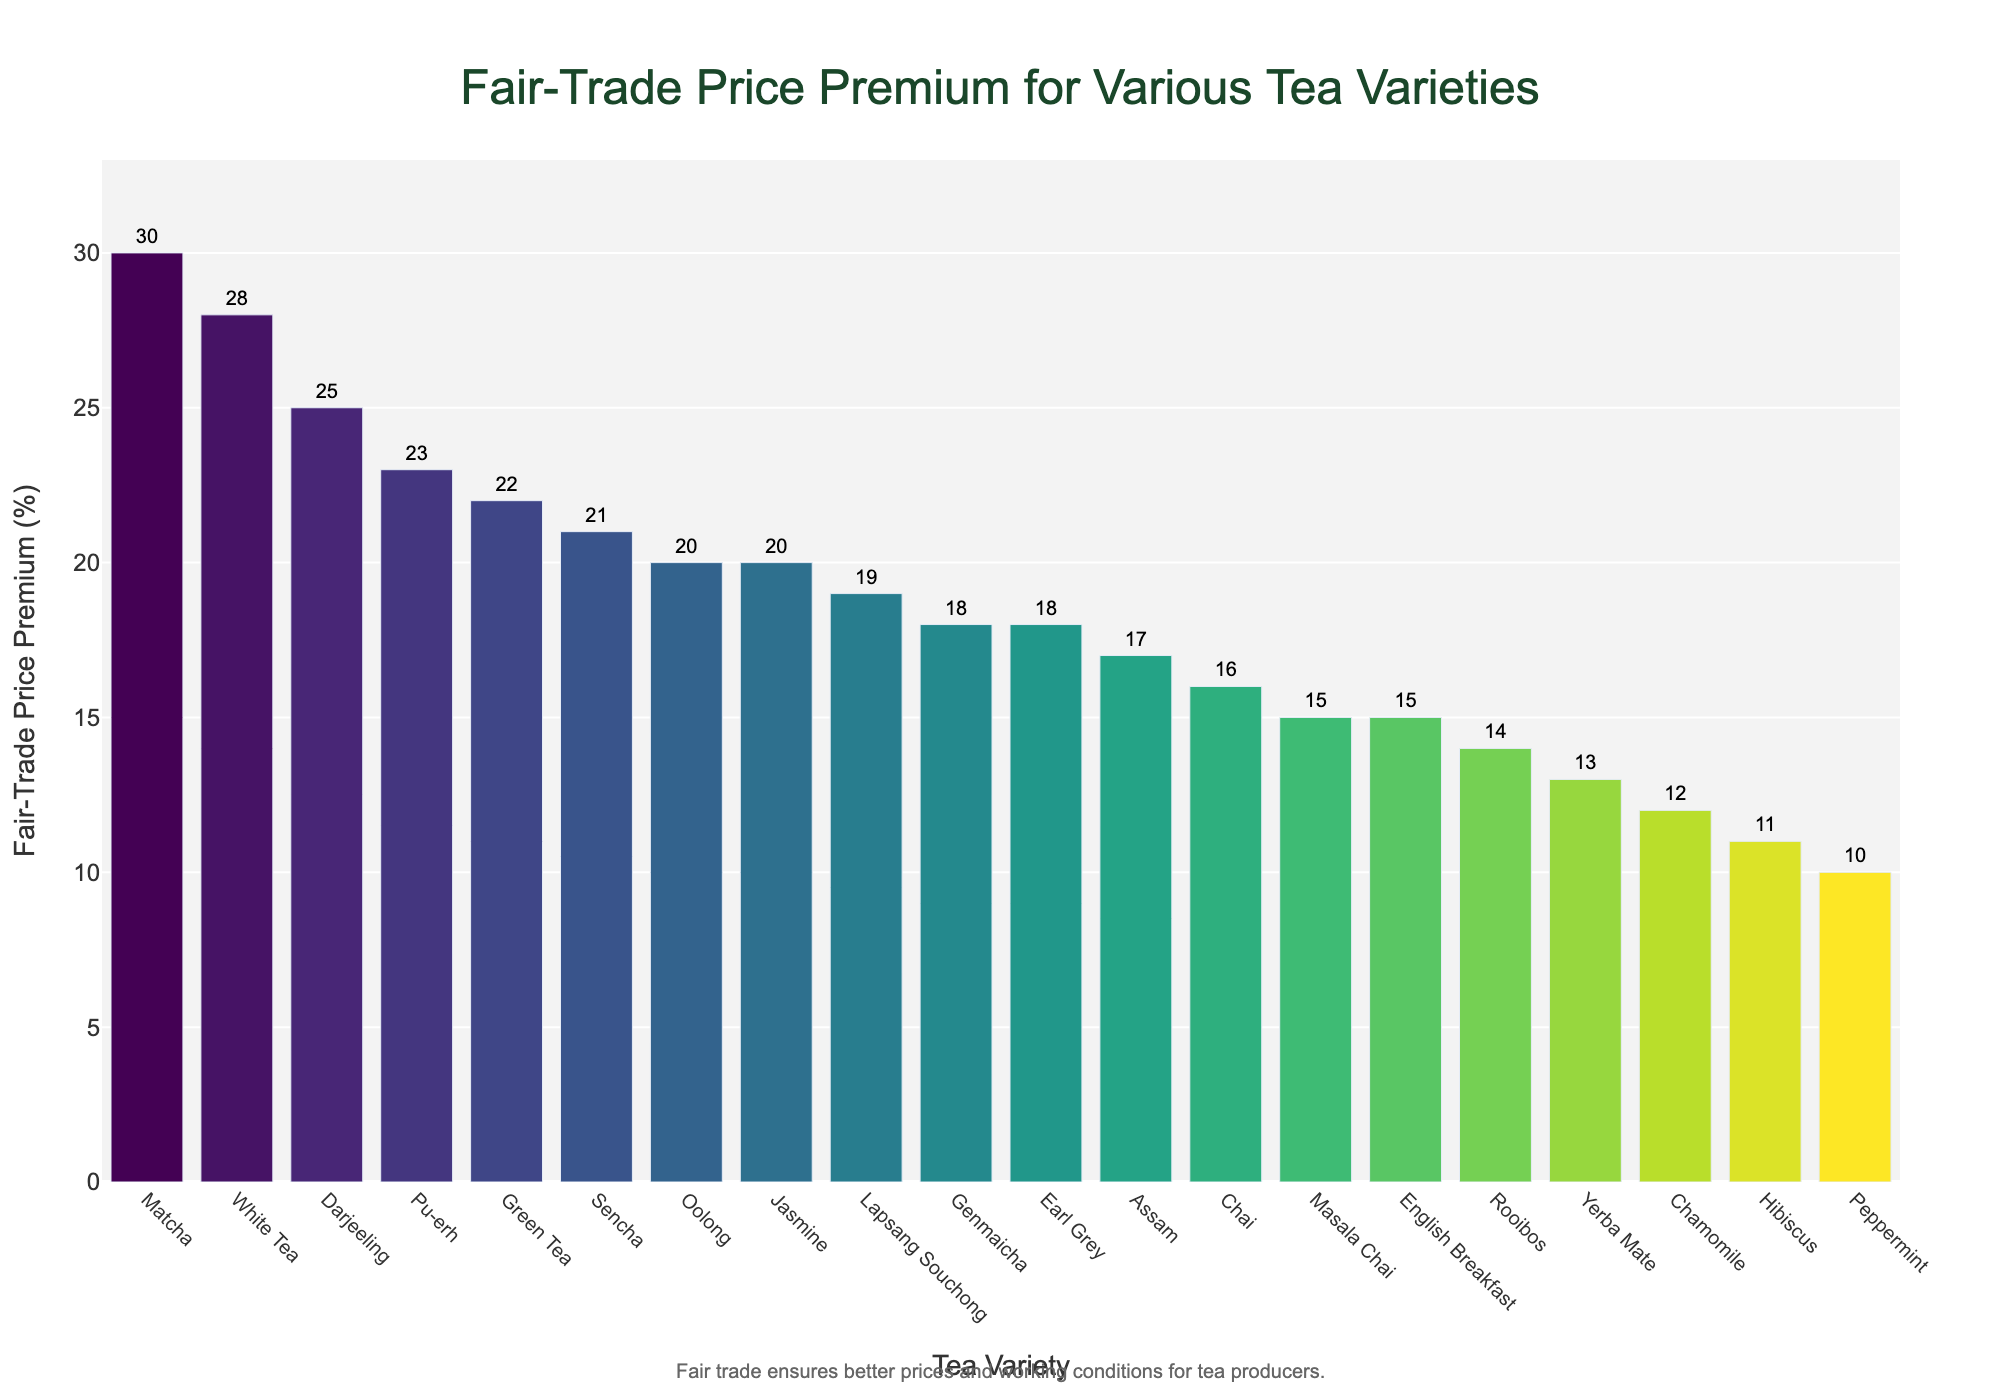Which tea variety has the highest Fair-Trade price premium? The bar representing "Matcha" is the tallest, indicating that it has the highest Fair-Trade price premium at 30%.
Answer: Matcha Which tea varieties have a Fair-Trade price premium of more than 25%? The Tea varieties with bars showing more than 25% are "Matcha" (30%), "White Tea" (28%), and "Darjeeling" (25%).
Answer: Matcha, White Tea, Darjeeling What is the difference in Fair-Trade price premium between the highest and lowest tea varieties? The highest Fair-Trade premium is for "Matcha" at 30% and the lowest is for "Peppermint" at 10%. The difference is 30% - 10% = 20%.
Answer: 20% Which tea varieties have a Fair-Trade price premium of exactly 20%? The bars for "Oolong" and "Jasmine" both reach the 20% mark.
Answer: Oolong, Jasmine What is the median Fair-Trade price premium of the tea varieties? To find the median, sort the values and find the middle one. The median value is "Sencha" at 21%.
Answer: 21% Compare the Fair-Trade price premium of "English Breakfast" and "Masala Chai". Which one is higher and by how much? The Fair-Trade price premium for "English Breakfast" is 15% and for "Masala Chai" it is also 15%, meaning they are equal.
Answer: They are equal What is the range of the Fair-Trade price premium among all the tea varieties? The range is calculated as the difference between the maximum and the minimum values. The highest premium is 30% for "Matcha" and the lowest is 10% for "Peppermint." So, 30% - 10% = 20%.
Answer: 20% Which two tea varieties that are next to each other on the bar chart have the closest Fair-Trade price premium values? "English Breakfast" (15%) and "Masala Chai" (15%) share the exact same premium values and are next to each other.
Answer: English Breakfast, Masala Chai What is the Fair-Trade price premium for "Chai" and how does it compare to "Lapsang Souchong"? The Fair-Trade price premium for "Chai" is 16%, while "Lapsang Souchong" has a 19% premium. The difference is 19% - 16% = 3%.
Answer: Chai has a 16% premium, 3% less than Lapsang Souchong 